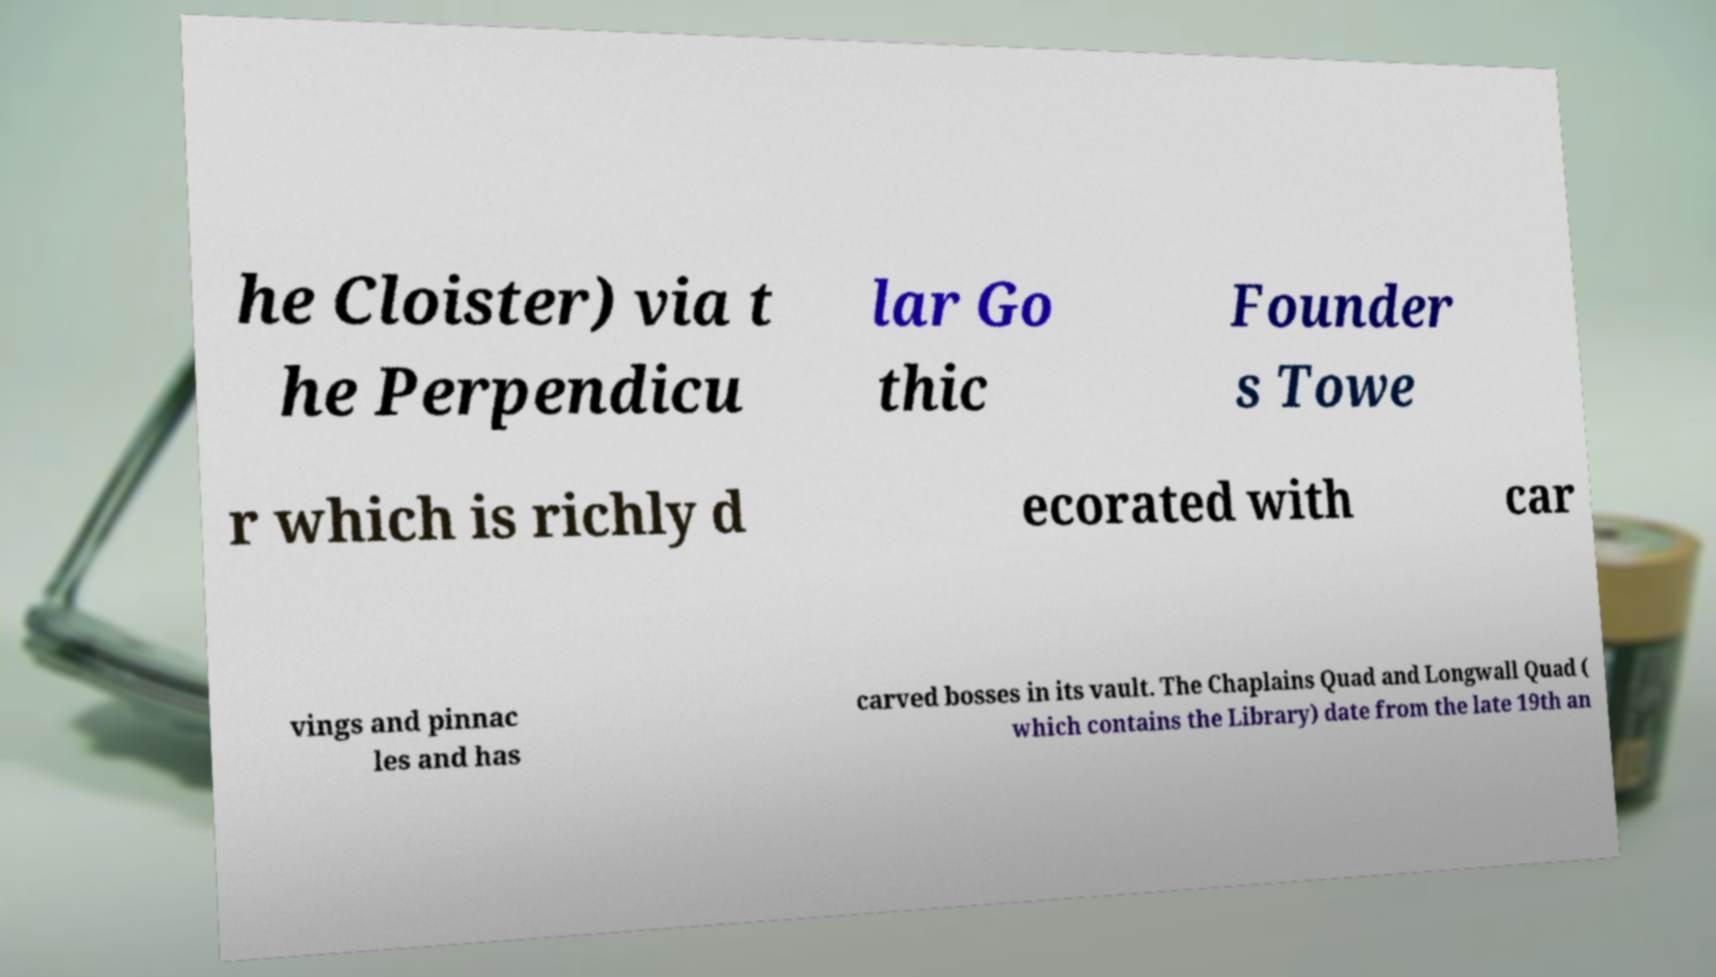Please identify and transcribe the text found in this image. he Cloister) via t he Perpendicu lar Go thic Founder s Towe r which is richly d ecorated with car vings and pinnac les and has carved bosses in its vault. The Chaplains Quad and Longwall Quad ( which contains the Library) date from the late 19th an 